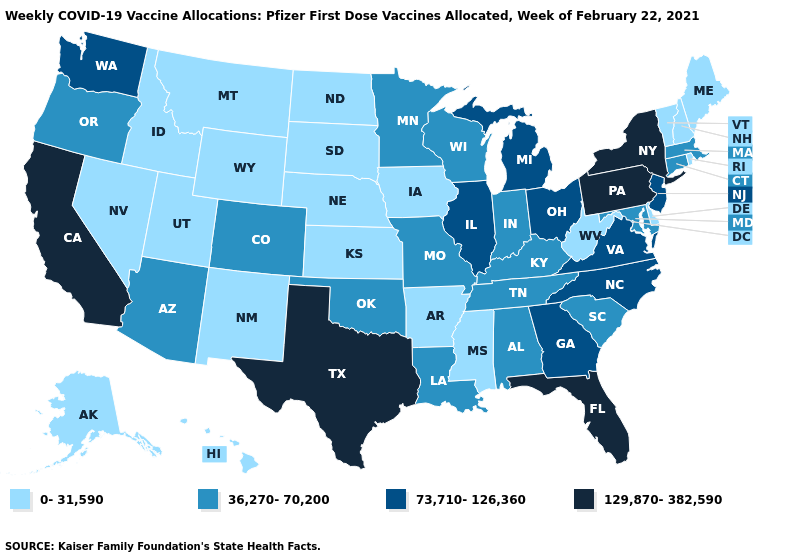Name the states that have a value in the range 73,710-126,360?
Concise answer only. Georgia, Illinois, Michigan, New Jersey, North Carolina, Ohio, Virginia, Washington. What is the highest value in the South ?
Give a very brief answer. 129,870-382,590. Name the states that have a value in the range 129,870-382,590?
Keep it brief. California, Florida, New York, Pennsylvania, Texas. Which states have the lowest value in the USA?
Short answer required. Alaska, Arkansas, Delaware, Hawaii, Idaho, Iowa, Kansas, Maine, Mississippi, Montana, Nebraska, Nevada, New Hampshire, New Mexico, North Dakota, Rhode Island, South Dakota, Utah, Vermont, West Virginia, Wyoming. What is the value of Alaska?
Answer briefly. 0-31,590. Does Maine have the lowest value in the Northeast?
Keep it brief. Yes. What is the value of Delaware?
Write a very short answer. 0-31,590. Among the states that border Wyoming , which have the highest value?
Give a very brief answer. Colorado. Which states have the lowest value in the West?
Be succinct. Alaska, Hawaii, Idaho, Montana, Nevada, New Mexico, Utah, Wyoming. Does West Virginia have the highest value in the South?
Keep it brief. No. What is the value of Kentucky?
Answer briefly. 36,270-70,200. What is the value of Florida?
Write a very short answer. 129,870-382,590. Among the states that border Nebraska , which have the highest value?
Concise answer only. Colorado, Missouri. Among the states that border California , which have the highest value?
Write a very short answer. Arizona, Oregon. What is the value of Wyoming?
Concise answer only. 0-31,590. 